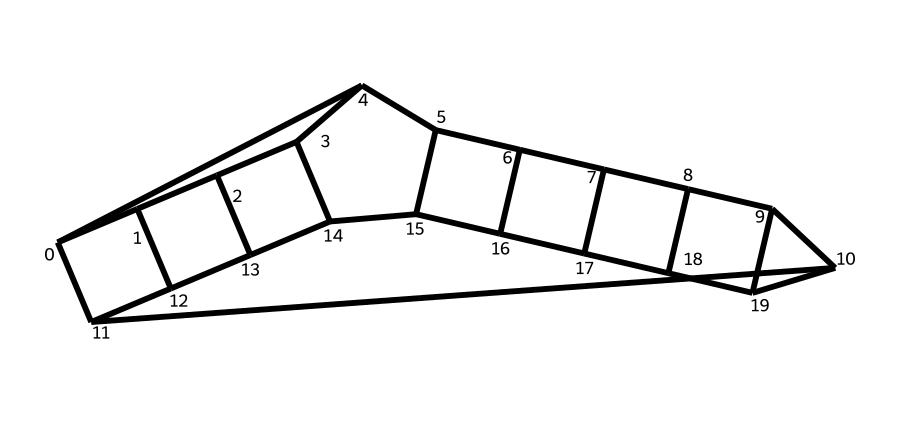How many carbon atoms are in dodecahedrane? The SMILES representation indicates that the structure contains 20 carbon atoms, as counted from the symbols representing carbon (C) throughout the notation.
Answer: 20 What is the molecular formula of dodecahedrane? Based on the number of carbon atoms (20) and the typical saturation for this type of compound, its molecular formula is C20H40. This is determined from the presence of carbon atoms and expectations around hydrogen saturation.
Answer: C20H40 How many hydrogen atoms are in dodecahedrane? Given the molecular formula C20H40, the number of hydrogen atoms can be identified as 40 directly from the formula, as it explicitly states the amount of hydrogen present.
Answer: 40 What type of structure does dodecahedrane possess? Dodecahedrane is classified as a cage compound due to its highly symmetrical arrangement of carbon atoms forming a closed framework. This is inferred from the way the carbon atoms are connected in a symmetrical pattern.
Answer: cage compound What is the symmetry of dodecahedrane? The structure is associated with icosahedral symmetry, which is a specific type of spherical symmetry characteristic of highly symmetrical cage compounds like dodecahedrane. The arrangement of carbon atoms reflects this symmetry.
Answer: icosahedral How does the cage structure of dodecahedrane affect its properties? The cage structure impacts the chemical properties such as stability and reactivity by providing a unique spatial arrangement of atoms, leading to distinct physical and chemical behaviors compared to linear or branched structures. This is deduced from general knowledge about cage compounds.
Answer: unique properties 